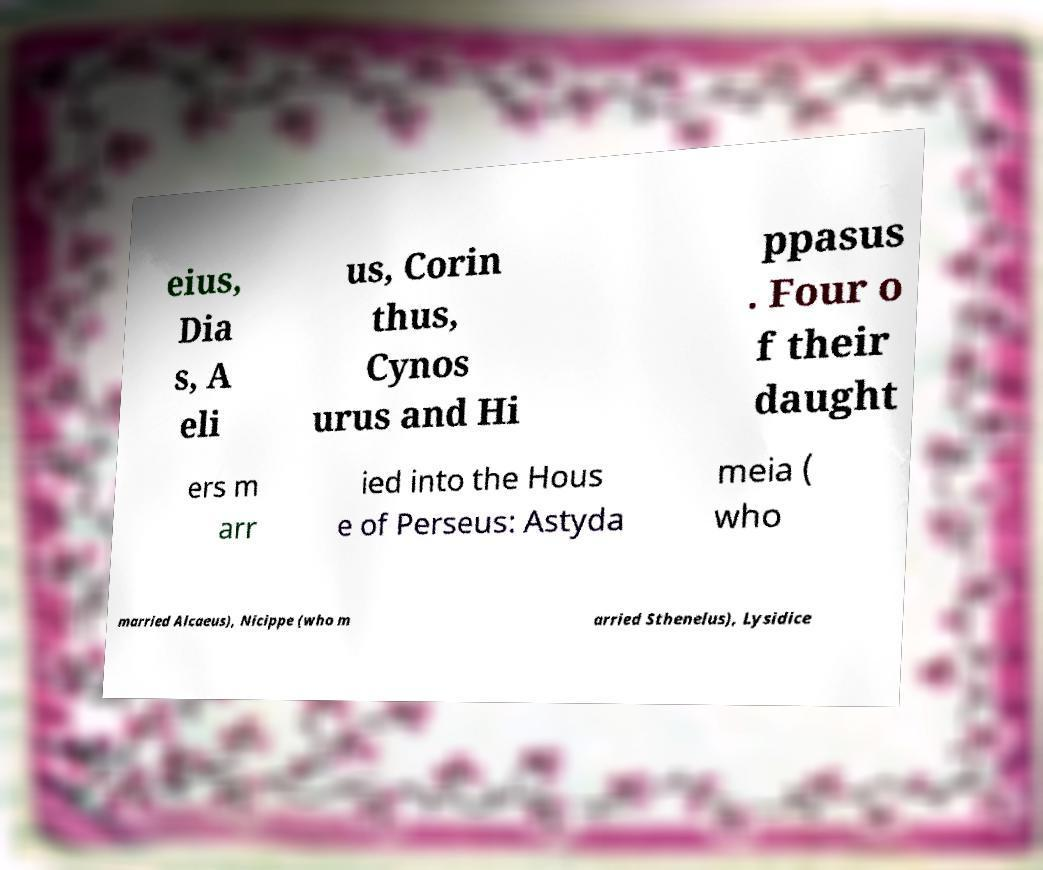Could you assist in decoding the text presented in this image and type it out clearly? eius, Dia s, A eli us, Corin thus, Cynos urus and Hi ppasus . Four o f their daught ers m arr ied into the Hous e of Perseus: Astyda meia ( who married Alcaeus), Nicippe (who m arried Sthenelus), Lysidice 